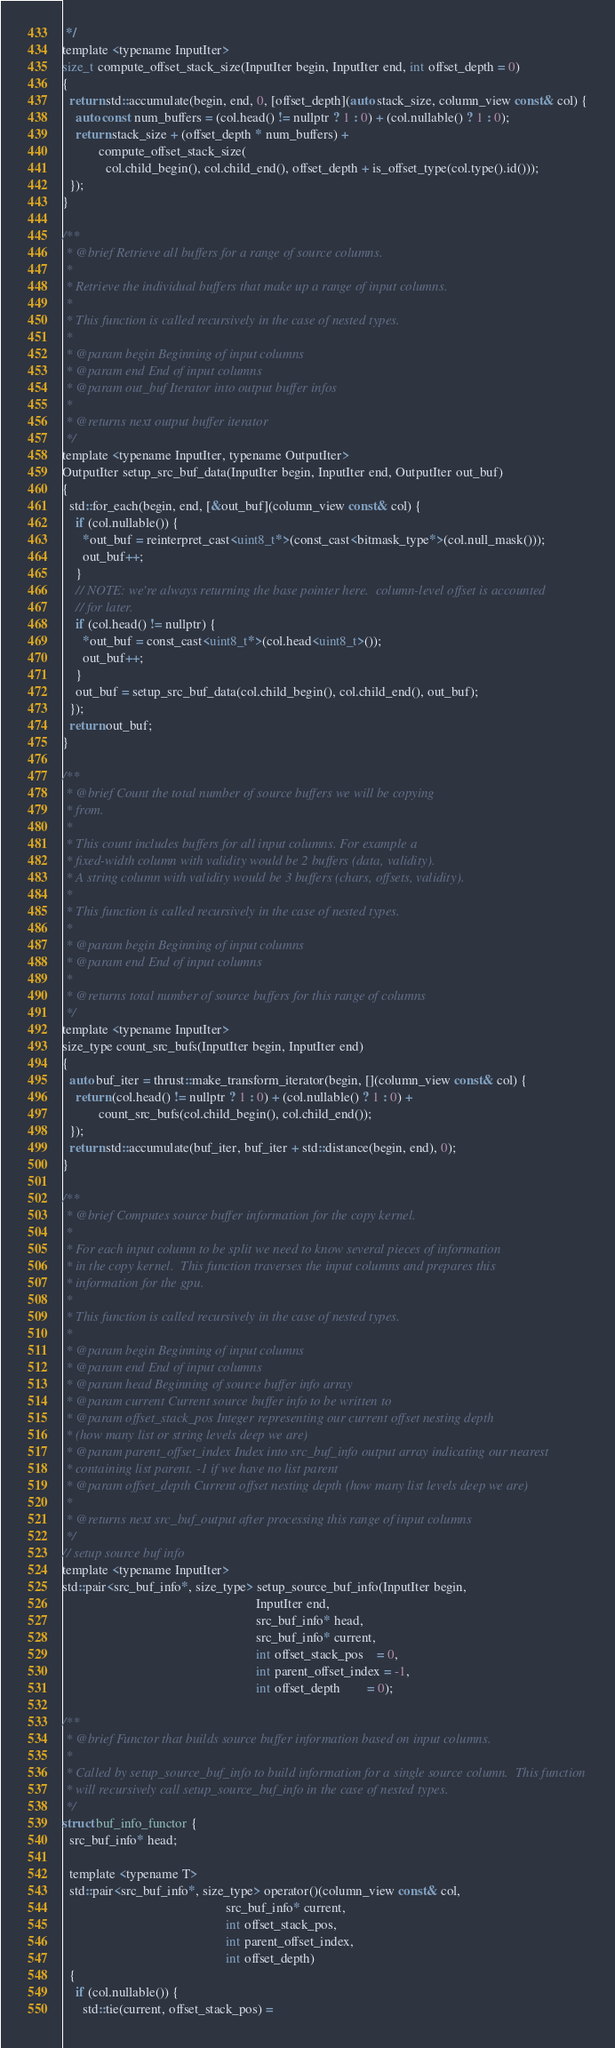Convert code to text. <code><loc_0><loc_0><loc_500><loc_500><_Cuda_> */
template <typename InputIter>
size_t compute_offset_stack_size(InputIter begin, InputIter end, int offset_depth = 0)
{
  return std::accumulate(begin, end, 0, [offset_depth](auto stack_size, column_view const& col) {
    auto const num_buffers = (col.head() != nullptr ? 1 : 0) + (col.nullable() ? 1 : 0);
    return stack_size + (offset_depth * num_buffers) +
           compute_offset_stack_size(
             col.child_begin(), col.child_end(), offset_depth + is_offset_type(col.type().id()));
  });
}

/**
 * @brief Retrieve all buffers for a range of source columns.
 *
 * Retrieve the individual buffers that make up a range of input columns.
 *
 * This function is called recursively in the case of nested types.
 *
 * @param begin Beginning of input columns
 * @param end End of input columns
 * @param out_buf Iterator into output buffer infos
 *
 * @returns next output buffer iterator
 */
template <typename InputIter, typename OutputIter>
OutputIter setup_src_buf_data(InputIter begin, InputIter end, OutputIter out_buf)
{
  std::for_each(begin, end, [&out_buf](column_view const& col) {
    if (col.nullable()) {
      *out_buf = reinterpret_cast<uint8_t*>(const_cast<bitmask_type*>(col.null_mask()));
      out_buf++;
    }
    // NOTE: we're always returning the base pointer here.  column-level offset is accounted
    // for later.
    if (col.head() != nullptr) {
      *out_buf = const_cast<uint8_t*>(col.head<uint8_t>());
      out_buf++;
    }
    out_buf = setup_src_buf_data(col.child_begin(), col.child_end(), out_buf);
  });
  return out_buf;
}

/**
 * @brief Count the total number of source buffers we will be copying
 * from.
 *
 * This count includes buffers for all input columns. For example a
 * fixed-width column with validity would be 2 buffers (data, validity).
 * A string column with validity would be 3 buffers (chars, offsets, validity).
 *
 * This function is called recursively in the case of nested types.
 *
 * @param begin Beginning of input columns
 * @param end End of input columns
 *
 * @returns total number of source buffers for this range of columns
 */
template <typename InputIter>
size_type count_src_bufs(InputIter begin, InputIter end)
{
  auto buf_iter = thrust::make_transform_iterator(begin, [](column_view const& col) {
    return (col.head() != nullptr ? 1 : 0) + (col.nullable() ? 1 : 0) +
           count_src_bufs(col.child_begin(), col.child_end());
  });
  return std::accumulate(buf_iter, buf_iter + std::distance(begin, end), 0);
}

/**
 * @brief Computes source buffer information for the copy kernel.
 *
 * For each input column to be split we need to know several pieces of information
 * in the copy kernel.  This function traverses the input columns and prepares this
 * information for the gpu.
 *
 * This function is called recursively in the case of nested types.
 *
 * @param begin Beginning of input columns
 * @param end End of input columns
 * @param head Beginning of source buffer info array
 * @param current Current source buffer info to be written to
 * @param offset_stack_pos Integer representing our current offset nesting depth
 * (how many list or string levels deep we are)
 * @param parent_offset_index Index into src_buf_info output array indicating our nearest
 * containing list parent. -1 if we have no list parent
 * @param offset_depth Current offset nesting depth (how many list levels deep we are)
 *
 * @returns next src_buf_output after processing this range of input columns
 */
// setup source buf info
template <typename InputIter>
std::pair<src_buf_info*, size_type> setup_source_buf_info(InputIter begin,
                                                          InputIter end,
                                                          src_buf_info* head,
                                                          src_buf_info* current,
                                                          int offset_stack_pos    = 0,
                                                          int parent_offset_index = -1,
                                                          int offset_depth        = 0);

/**
 * @brief Functor that builds source buffer information based on input columns.
 *
 * Called by setup_source_buf_info to build information for a single source column.  This function
 * will recursively call setup_source_buf_info in the case of nested types.
 */
struct buf_info_functor {
  src_buf_info* head;

  template <typename T>
  std::pair<src_buf_info*, size_type> operator()(column_view const& col,
                                                 src_buf_info* current,
                                                 int offset_stack_pos,
                                                 int parent_offset_index,
                                                 int offset_depth)
  {
    if (col.nullable()) {
      std::tie(current, offset_stack_pos) =</code> 